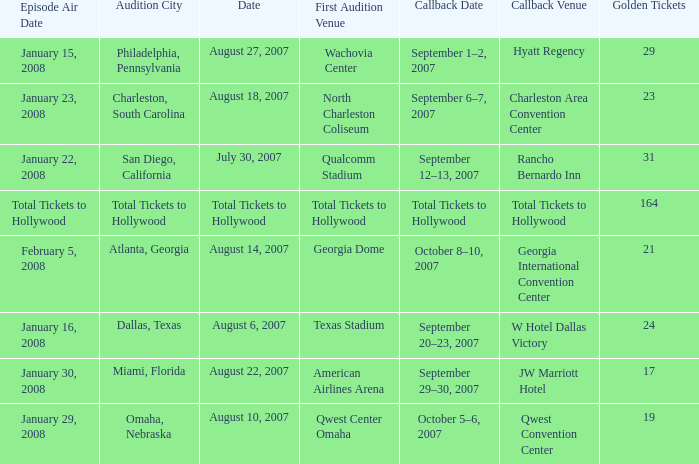What audition city has a Callback Date of october 5–6, 2007? Omaha, Nebraska. 